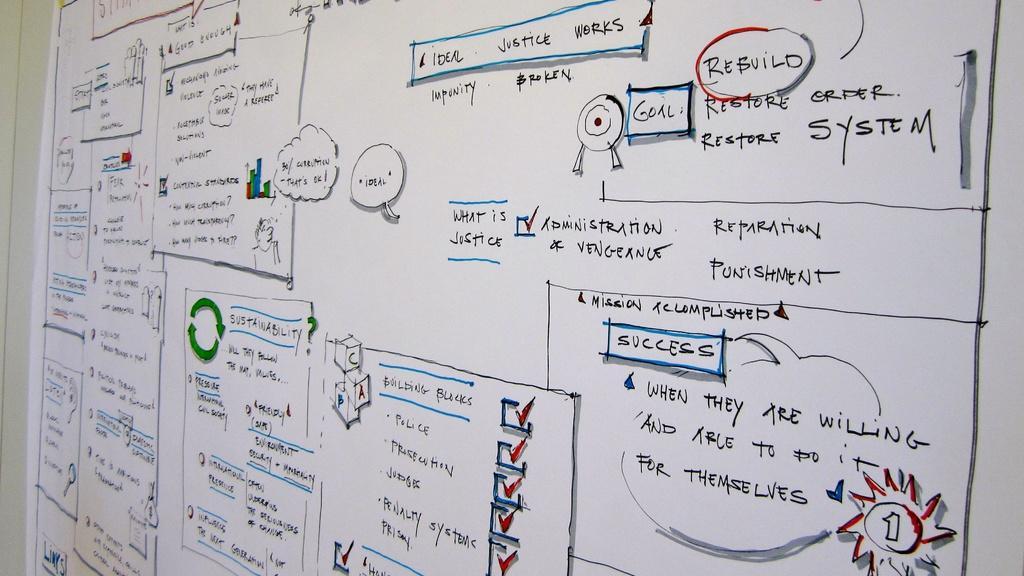Describe this image in one or two sentences. In this image I see a white color sheet which consists of black color text on it. 